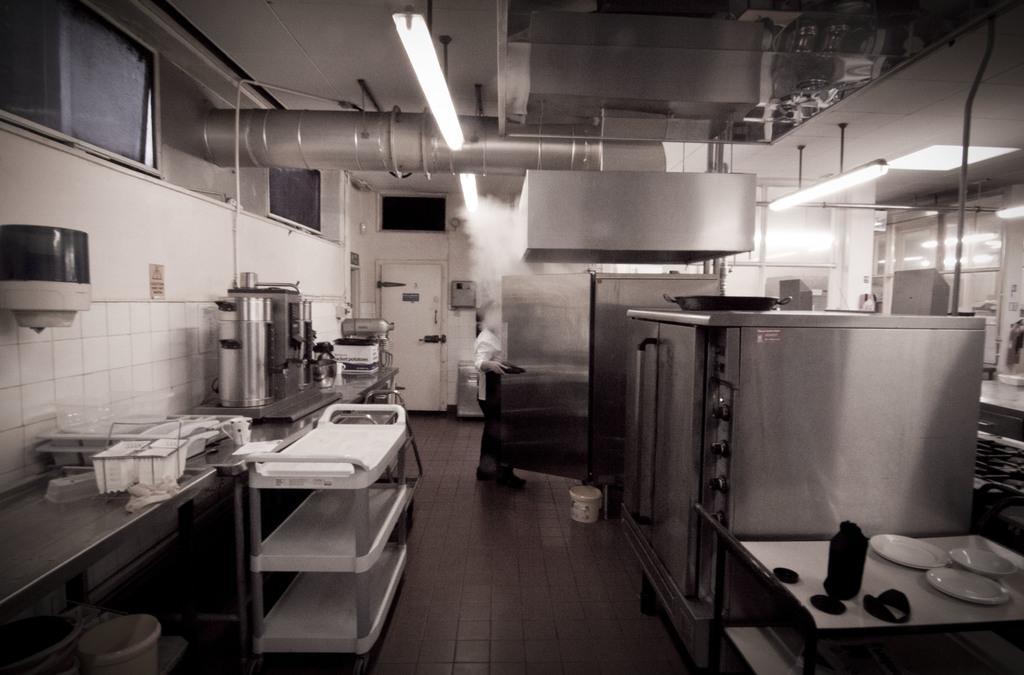Please provide a concise description of this image. In this picture on the right side there are some containers, tables. On the tables there are some plates and also there are some lights, wall, glass windows. On the left side there is a table, on the table there are some machines, baskets, trays and tables and buckets and in the center there is one person who is standing and he is opening a door. And on the top there is a light and one pipe and ceiling in the center there is one door, and also we could see some windows. At the bottom there is a floor. 